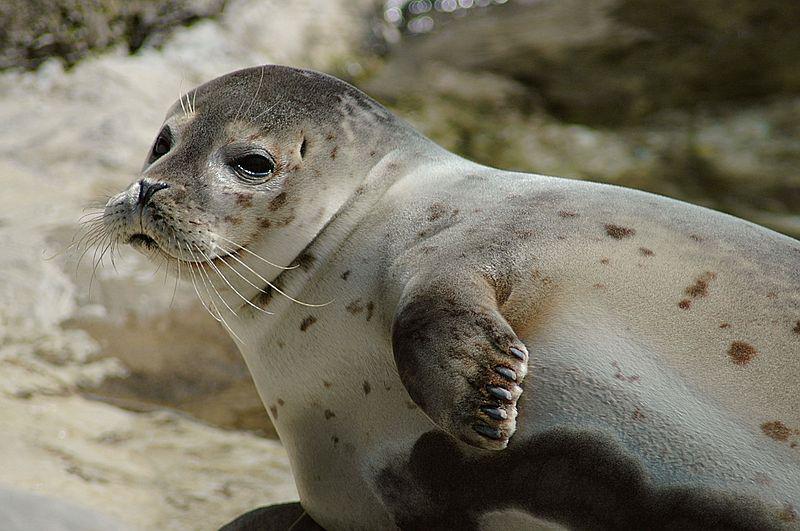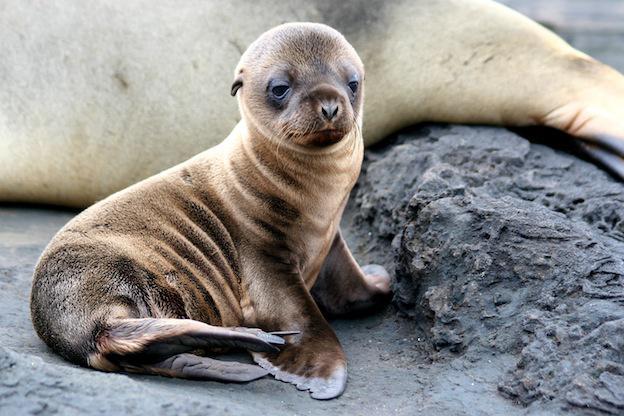The first image is the image on the left, the second image is the image on the right. For the images displayed, is the sentence "One seal has its mouth open, and another one does not." factually correct? Answer yes or no. No. The first image is the image on the left, the second image is the image on the right. Examine the images to the left and right. Is the description "A single seal is standing on top of a rock with its mouth open." accurate? Answer yes or no. No. 